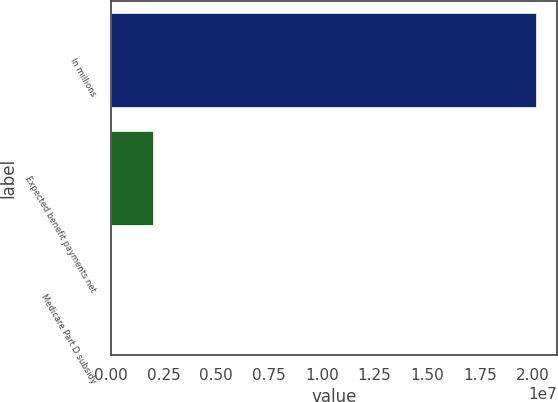<chart> <loc_0><loc_0><loc_500><loc_500><bar_chart><fcel>In millions<fcel>Expected benefit payments net<fcel>Medicare Part D subsidy<nl><fcel>2.0152e+07<fcel>2.01521e+06<fcel>12<nl></chart> 